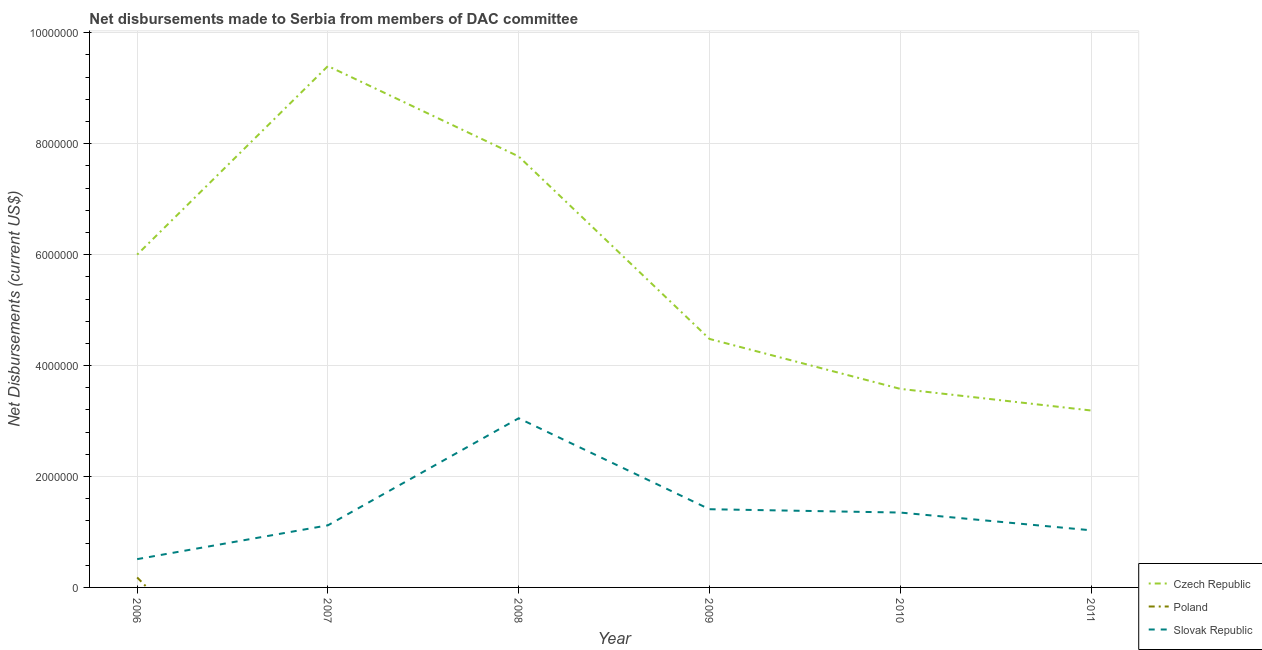Does the line corresponding to net disbursements made by slovak republic intersect with the line corresponding to net disbursements made by czech republic?
Your response must be concise. No. Is the number of lines equal to the number of legend labels?
Your answer should be very brief. No. Across all years, what is the maximum net disbursements made by czech republic?
Offer a very short reply. 9.40e+06. Across all years, what is the minimum net disbursements made by poland?
Your answer should be compact. 0. In which year was the net disbursements made by poland maximum?
Your response must be concise. 2006. What is the total net disbursements made by poland in the graph?
Your answer should be compact. 1.80e+05. What is the difference between the net disbursements made by slovak republic in 2008 and that in 2010?
Give a very brief answer. 1.70e+06. What is the difference between the net disbursements made by czech republic in 2010 and the net disbursements made by poland in 2011?
Your response must be concise. 3.58e+06. What is the average net disbursements made by poland per year?
Keep it short and to the point. 3.00e+04. In the year 2010, what is the difference between the net disbursements made by slovak republic and net disbursements made by czech republic?
Offer a very short reply. -2.23e+06. In how many years, is the net disbursements made by slovak republic greater than 7200000 US$?
Provide a succinct answer. 0. What is the ratio of the net disbursements made by slovak republic in 2006 to that in 2011?
Ensure brevity in your answer.  0.5. Is the net disbursements made by czech republic in 2008 less than that in 2011?
Offer a very short reply. No. What is the difference between the highest and the second highest net disbursements made by czech republic?
Your answer should be compact. 1.63e+06. What is the difference between the highest and the lowest net disbursements made by czech republic?
Provide a succinct answer. 6.21e+06. Is the sum of the net disbursements made by slovak republic in 2009 and 2011 greater than the maximum net disbursements made by czech republic across all years?
Give a very brief answer. No. Is it the case that in every year, the sum of the net disbursements made by czech republic and net disbursements made by poland is greater than the net disbursements made by slovak republic?
Ensure brevity in your answer.  Yes. Does the net disbursements made by poland monotonically increase over the years?
Your answer should be compact. No. Is the net disbursements made by slovak republic strictly greater than the net disbursements made by poland over the years?
Provide a succinct answer. Yes. Is the net disbursements made by czech republic strictly less than the net disbursements made by slovak republic over the years?
Keep it short and to the point. No. How many lines are there?
Give a very brief answer. 3. How many years are there in the graph?
Provide a short and direct response. 6. Are the values on the major ticks of Y-axis written in scientific E-notation?
Your response must be concise. No. Does the graph contain any zero values?
Your answer should be compact. Yes. What is the title of the graph?
Provide a succinct answer. Net disbursements made to Serbia from members of DAC committee. What is the label or title of the Y-axis?
Keep it short and to the point. Net Disbursements (current US$). What is the Net Disbursements (current US$) in Poland in 2006?
Offer a very short reply. 1.80e+05. What is the Net Disbursements (current US$) in Slovak Republic in 2006?
Your answer should be very brief. 5.10e+05. What is the Net Disbursements (current US$) of Czech Republic in 2007?
Your answer should be very brief. 9.40e+06. What is the Net Disbursements (current US$) in Poland in 2007?
Provide a short and direct response. 0. What is the Net Disbursements (current US$) of Slovak Republic in 2007?
Provide a succinct answer. 1.12e+06. What is the Net Disbursements (current US$) in Czech Republic in 2008?
Provide a succinct answer. 7.77e+06. What is the Net Disbursements (current US$) of Slovak Republic in 2008?
Your answer should be very brief. 3.05e+06. What is the Net Disbursements (current US$) of Czech Republic in 2009?
Your answer should be compact. 4.48e+06. What is the Net Disbursements (current US$) in Poland in 2009?
Make the answer very short. 0. What is the Net Disbursements (current US$) in Slovak Republic in 2009?
Give a very brief answer. 1.41e+06. What is the Net Disbursements (current US$) of Czech Republic in 2010?
Your answer should be very brief. 3.58e+06. What is the Net Disbursements (current US$) of Poland in 2010?
Your answer should be very brief. 0. What is the Net Disbursements (current US$) in Slovak Republic in 2010?
Ensure brevity in your answer.  1.35e+06. What is the Net Disbursements (current US$) in Czech Republic in 2011?
Keep it short and to the point. 3.19e+06. What is the Net Disbursements (current US$) in Poland in 2011?
Provide a succinct answer. 0. What is the Net Disbursements (current US$) in Slovak Republic in 2011?
Keep it short and to the point. 1.03e+06. Across all years, what is the maximum Net Disbursements (current US$) of Czech Republic?
Your answer should be compact. 9.40e+06. Across all years, what is the maximum Net Disbursements (current US$) of Slovak Republic?
Your answer should be compact. 3.05e+06. Across all years, what is the minimum Net Disbursements (current US$) of Czech Republic?
Offer a terse response. 3.19e+06. Across all years, what is the minimum Net Disbursements (current US$) in Poland?
Ensure brevity in your answer.  0. Across all years, what is the minimum Net Disbursements (current US$) in Slovak Republic?
Your answer should be compact. 5.10e+05. What is the total Net Disbursements (current US$) in Czech Republic in the graph?
Provide a short and direct response. 3.44e+07. What is the total Net Disbursements (current US$) in Poland in the graph?
Keep it short and to the point. 1.80e+05. What is the total Net Disbursements (current US$) in Slovak Republic in the graph?
Offer a terse response. 8.47e+06. What is the difference between the Net Disbursements (current US$) in Czech Republic in 2006 and that in 2007?
Your answer should be very brief. -3.40e+06. What is the difference between the Net Disbursements (current US$) in Slovak Republic in 2006 and that in 2007?
Offer a terse response. -6.10e+05. What is the difference between the Net Disbursements (current US$) in Czech Republic in 2006 and that in 2008?
Provide a short and direct response. -1.77e+06. What is the difference between the Net Disbursements (current US$) of Slovak Republic in 2006 and that in 2008?
Your answer should be compact. -2.54e+06. What is the difference between the Net Disbursements (current US$) of Czech Republic in 2006 and that in 2009?
Offer a very short reply. 1.52e+06. What is the difference between the Net Disbursements (current US$) of Slovak Republic in 2006 and that in 2009?
Offer a terse response. -9.00e+05. What is the difference between the Net Disbursements (current US$) of Czech Republic in 2006 and that in 2010?
Give a very brief answer. 2.42e+06. What is the difference between the Net Disbursements (current US$) of Slovak Republic in 2006 and that in 2010?
Your answer should be compact. -8.40e+05. What is the difference between the Net Disbursements (current US$) in Czech Republic in 2006 and that in 2011?
Make the answer very short. 2.81e+06. What is the difference between the Net Disbursements (current US$) in Slovak Republic in 2006 and that in 2011?
Offer a terse response. -5.20e+05. What is the difference between the Net Disbursements (current US$) of Czech Republic in 2007 and that in 2008?
Offer a very short reply. 1.63e+06. What is the difference between the Net Disbursements (current US$) of Slovak Republic in 2007 and that in 2008?
Provide a succinct answer. -1.93e+06. What is the difference between the Net Disbursements (current US$) of Czech Republic in 2007 and that in 2009?
Offer a terse response. 4.92e+06. What is the difference between the Net Disbursements (current US$) of Slovak Republic in 2007 and that in 2009?
Your response must be concise. -2.90e+05. What is the difference between the Net Disbursements (current US$) of Czech Republic in 2007 and that in 2010?
Offer a terse response. 5.82e+06. What is the difference between the Net Disbursements (current US$) of Czech Republic in 2007 and that in 2011?
Make the answer very short. 6.21e+06. What is the difference between the Net Disbursements (current US$) of Czech Republic in 2008 and that in 2009?
Offer a very short reply. 3.29e+06. What is the difference between the Net Disbursements (current US$) in Slovak Republic in 2008 and that in 2009?
Your answer should be very brief. 1.64e+06. What is the difference between the Net Disbursements (current US$) of Czech Republic in 2008 and that in 2010?
Provide a short and direct response. 4.19e+06. What is the difference between the Net Disbursements (current US$) of Slovak Republic in 2008 and that in 2010?
Give a very brief answer. 1.70e+06. What is the difference between the Net Disbursements (current US$) in Czech Republic in 2008 and that in 2011?
Make the answer very short. 4.58e+06. What is the difference between the Net Disbursements (current US$) in Slovak Republic in 2008 and that in 2011?
Offer a very short reply. 2.02e+06. What is the difference between the Net Disbursements (current US$) in Slovak Republic in 2009 and that in 2010?
Make the answer very short. 6.00e+04. What is the difference between the Net Disbursements (current US$) in Czech Republic in 2009 and that in 2011?
Your response must be concise. 1.29e+06. What is the difference between the Net Disbursements (current US$) in Slovak Republic in 2010 and that in 2011?
Your answer should be very brief. 3.20e+05. What is the difference between the Net Disbursements (current US$) in Czech Republic in 2006 and the Net Disbursements (current US$) in Slovak Republic in 2007?
Your answer should be very brief. 4.88e+06. What is the difference between the Net Disbursements (current US$) in Poland in 2006 and the Net Disbursements (current US$) in Slovak Republic in 2007?
Give a very brief answer. -9.40e+05. What is the difference between the Net Disbursements (current US$) of Czech Republic in 2006 and the Net Disbursements (current US$) of Slovak Republic in 2008?
Your answer should be very brief. 2.95e+06. What is the difference between the Net Disbursements (current US$) of Poland in 2006 and the Net Disbursements (current US$) of Slovak Republic in 2008?
Offer a terse response. -2.87e+06. What is the difference between the Net Disbursements (current US$) of Czech Republic in 2006 and the Net Disbursements (current US$) of Slovak Republic in 2009?
Offer a terse response. 4.59e+06. What is the difference between the Net Disbursements (current US$) of Poland in 2006 and the Net Disbursements (current US$) of Slovak Republic in 2009?
Your response must be concise. -1.23e+06. What is the difference between the Net Disbursements (current US$) of Czech Republic in 2006 and the Net Disbursements (current US$) of Slovak Republic in 2010?
Your answer should be very brief. 4.65e+06. What is the difference between the Net Disbursements (current US$) of Poland in 2006 and the Net Disbursements (current US$) of Slovak Republic in 2010?
Keep it short and to the point. -1.17e+06. What is the difference between the Net Disbursements (current US$) in Czech Republic in 2006 and the Net Disbursements (current US$) in Slovak Republic in 2011?
Keep it short and to the point. 4.97e+06. What is the difference between the Net Disbursements (current US$) of Poland in 2006 and the Net Disbursements (current US$) of Slovak Republic in 2011?
Provide a short and direct response. -8.50e+05. What is the difference between the Net Disbursements (current US$) in Czech Republic in 2007 and the Net Disbursements (current US$) in Slovak Republic in 2008?
Make the answer very short. 6.35e+06. What is the difference between the Net Disbursements (current US$) in Czech Republic in 2007 and the Net Disbursements (current US$) in Slovak Republic in 2009?
Offer a very short reply. 7.99e+06. What is the difference between the Net Disbursements (current US$) in Czech Republic in 2007 and the Net Disbursements (current US$) in Slovak Republic in 2010?
Give a very brief answer. 8.05e+06. What is the difference between the Net Disbursements (current US$) of Czech Republic in 2007 and the Net Disbursements (current US$) of Slovak Republic in 2011?
Your answer should be compact. 8.37e+06. What is the difference between the Net Disbursements (current US$) of Czech Republic in 2008 and the Net Disbursements (current US$) of Slovak Republic in 2009?
Make the answer very short. 6.36e+06. What is the difference between the Net Disbursements (current US$) of Czech Republic in 2008 and the Net Disbursements (current US$) of Slovak Republic in 2010?
Your answer should be very brief. 6.42e+06. What is the difference between the Net Disbursements (current US$) in Czech Republic in 2008 and the Net Disbursements (current US$) in Slovak Republic in 2011?
Provide a succinct answer. 6.74e+06. What is the difference between the Net Disbursements (current US$) in Czech Republic in 2009 and the Net Disbursements (current US$) in Slovak Republic in 2010?
Your response must be concise. 3.13e+06. What is the difference between the Net Disbursements (current US$) in Czech Republic in 2009 and the Net Disbursements (current US$) in Slovak Republic in 2011?
Your answer should be very brief. 3.45e+06. What is the difference between the Net Disbursements (current US$) in Czech Republic in 2010 and the Net Disbursements (current US$) in Slovak Republic in 2011?
Your answer should be compact. 2.55e+06. What is the average Net Disbursements (current US$) in Czech Republic per year?
Your response must be concise. 5.74e+06. What is the average Net Disbursements (current US$) in Poland per year?
Your answer should be compact. 3.00e+04. What is the average Net Disbursements (current US$) in Slovak Republic per year?
Provide a succinct answer. 1.41e+06. In the year 2006, what is the difference between the Net Disbursements (current US$) in Czech Republic and Net Disbursements (current US$) in Poland?
Your answer should be compact. 5.82e+06. In the year 2006, what is the difference between the Net Disbursements (current US$) of Czech Republic and Net Disbursements (current US$) of Slovak Republic?
Ensure brevity in your answer.  5.49e+06. In the year 2006, what is the difference between the Net Disbursements (current US$) in Poland and Net Disbursements (current US$) in Slovak Republic?
Provide a short and direct response. -3.30e+05. In the year 2007, what is the difference between the Net Disbursements (current US$) of Czech Republic and Net Disbursements (current US$) of Slovak Republic?
Offer a very short reply. 8.28e+06. In the year 2008, what is the difference between the Net Disbursements (current US$) of Czech Republic and Net Disbursements (current US$) of Slovak Republic?
Provide a short and direct response. 4.72e+06. In the year 2009, what is the difference between the Net Disbursements (current US$) of Czech Republic and Net Disbursements (current US$) of Slovak Republic?
Offer a very short reply. 3.07e+06. In the year 2010, what is the difference between the Net Disbursements (current US$) in Czech Republic and Net Disbursements (current US$) in Slovak Republic?
Your answer should be compact. 2.23e+06. In the year 2011, what is the difference between the Net Disbursements (current US$) of Czech Republic and Net Disbursements (current US$) of Slovak Republic?
Provide a succinct answer. 2.16e+06. What is the ratio of the Net Disbursements (current US$) of Czech Republic in 2006 to that in 2007?
Your answer should be very brief. 0.64. What is the ratio of the Net Disbursements (current US$) in Slovak Republic in 2006 to that in 2007?
Give a very brief answer. 0.46. What is the ratio of the Net Disbursements (current US$) of Czech Republic in 2006 to that in 2008?
Offer a very short reply. 0.77. What is the ratio of the Net Disbursements (current US$) of Slovak Republic in 2006 to that in 2008?
Make the answer very short. 0.17. What is the ratio of the Net Disbursements (current US$) in Czech Republic in 2006 to that in 2009?
Your answer should be compact. 1.34. What is the ratio of the Net Disbursements (current US$) of Slovak Republic in 2006 to that in 2009?
Offer a very short reply. 0.36. What is the ratio of the Net Disbursements (current US$) in Czech Republic in 2006 to that in 2010?
Your response must be concise. 1.68. What is the ratio of the Net Disbursements (current US$) of Slovak Republic in 2006 to that in 2010?
Offer a very short reply. 0.38. What is the ratio of the Net Disbursements (current US$) in Czech Republic in 2006 to that in 2011?
Your response must be concise. 1.88. What is the ratio of the Net Disbursements (current US$) of Slovak Republic in 2006 to that in 2011?
Provide a short and direct response. 0.5. What is the ratio of the Net Disbursements (current US$) of Czech Republic in 2007 to that in 2008?
Make the answer very short. 1.21. What is the ratio of the Net Disbursements (current US$) of Slovak Republic in 2007 to that in 2008?
Ensure brevity in your answer.  0.37. What is the ratio of the Net Disbursements (current US$) in Czech Republic in 2007 to that in 2009?
Offer a very short reply. 2.1. What is the ratio of the Net Disbursements (current US$) in Slovak Republic in 2007 to that in 2009?
Keep it short and to the point. 0.79. What is the ratio of the Net Disbursements (current US$) of Czech Republic in 2007 to that in 2010?
Ensure brevity in your answer.  2.63. What is the ratio of the Net Disbursements (current US$) in Slovak Republic in 2007 to that in 2010?
Your response must be concise. 0.83. What is the ratio of the Net Disbursements (current US$) of Czech Republic in 2007 to that in 2011?
Ensure brevity in your answer.  2.95. What is the ratio of the Net Disbursements (current US$) of Slovak Republic in 2007 to that in 2011?
Ensure brevity in your answer.  1.09. What is the ratio of the Net Disbursements (current US$) of Czech Republic in 2008 to that in 2009?
Your answer should be compact. 1.73. What is the ratio of the Net Disbursements (current US$) of Slovak Republic in 2008 to that in 2009?
Offer a terse response. 2.16. What is the ratio of the Net Disbursements (current US$) in Czech Republic in 2008 to that in 2010?
Your response must be concise. 2.17. What is the ratio of the Net Disbursements (current US$) in Slovak Republic in 2008 to that in 2010?
Provide a succinct answer. 2.26. What is the ratio of the Net Disbursements (current US$) in Czech Republic in 2008 to that in 2011?
Ensure brevity in your answer.  2.44. What is the ratio of the Net Disbursements (current US$) of Slovak Republic in 2008 to that in 2011?
Your answer should be very brief. 2.96. What is the ratio of the Net Disbursements (current US$) of Czech Republic in 2009 to that in 2010?
Offer a terse response. 1.25. What is the ratio of the Net Disbursements (current US$) of Slovak Republic in 2009 to that in 2010?
Offer a very short reply. 1.04. What is the ratio of the Net Disbursements (current US$) in Czech Republic in 2009 to that in 2011?
Offer a very short reply. 1.4. What is the ratio of the Net Disbursements (current US$) in Slovak Republic in 2009 to that in 2011?
Provide a succinct answer. 1.37. What is the ratio of the Net Disbursements (current US$) of Czech Republic in 2010 to that in 2011?
Ensure brevity in your answer.  1.12. What is the ratio of the Net Disbursements (current US$) of Slovak Republic in 2010 to that in 2011?
Provide a short and direct response. 1.31. What is the difference between the highest and the second highest Net Disbursements (current US$) in Czech Republic?
Make the answer very short. 1.63e+06. What is the difference between the highest and the second highest Net Disbursements (current US$) of Slovak Republic?
Offer a very short reply. 1.64e+06. What is the difference between the highest and the lowest Net Disbursements (current US$) of Czech Republic?
Your response must be concise. 6.21e+06. What is the difference between the highest and the lowest Net Disbursements (current US$) in Slovak Republic?
Your answer should be compact. 2.54e+06. 